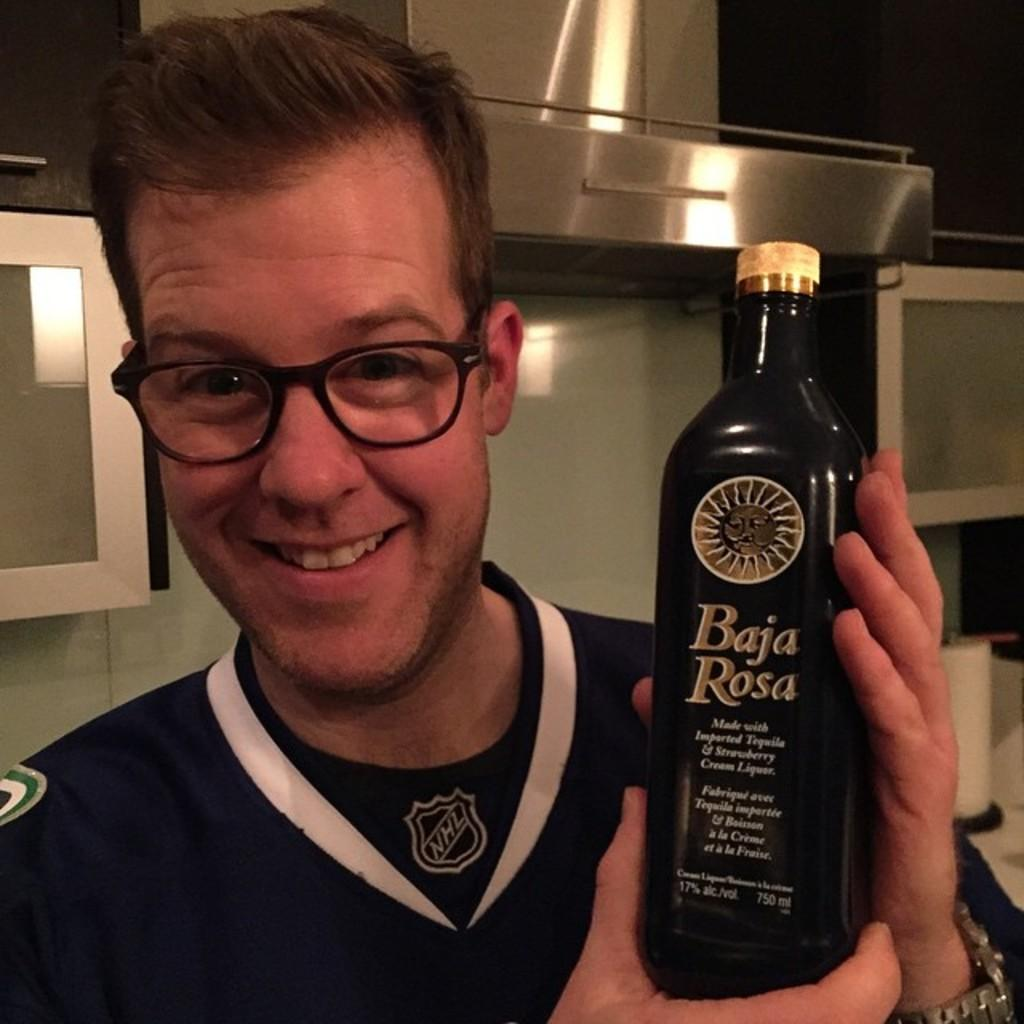<image>
Offer a succinct explanation of the picture presented. Baja Rosa is made with tequila and with strawberries. 